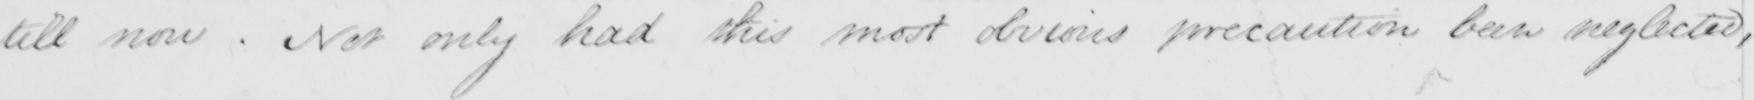Can you read and transcribe this handwriting? till now . Not only had this most obvious precaution been neglected , 